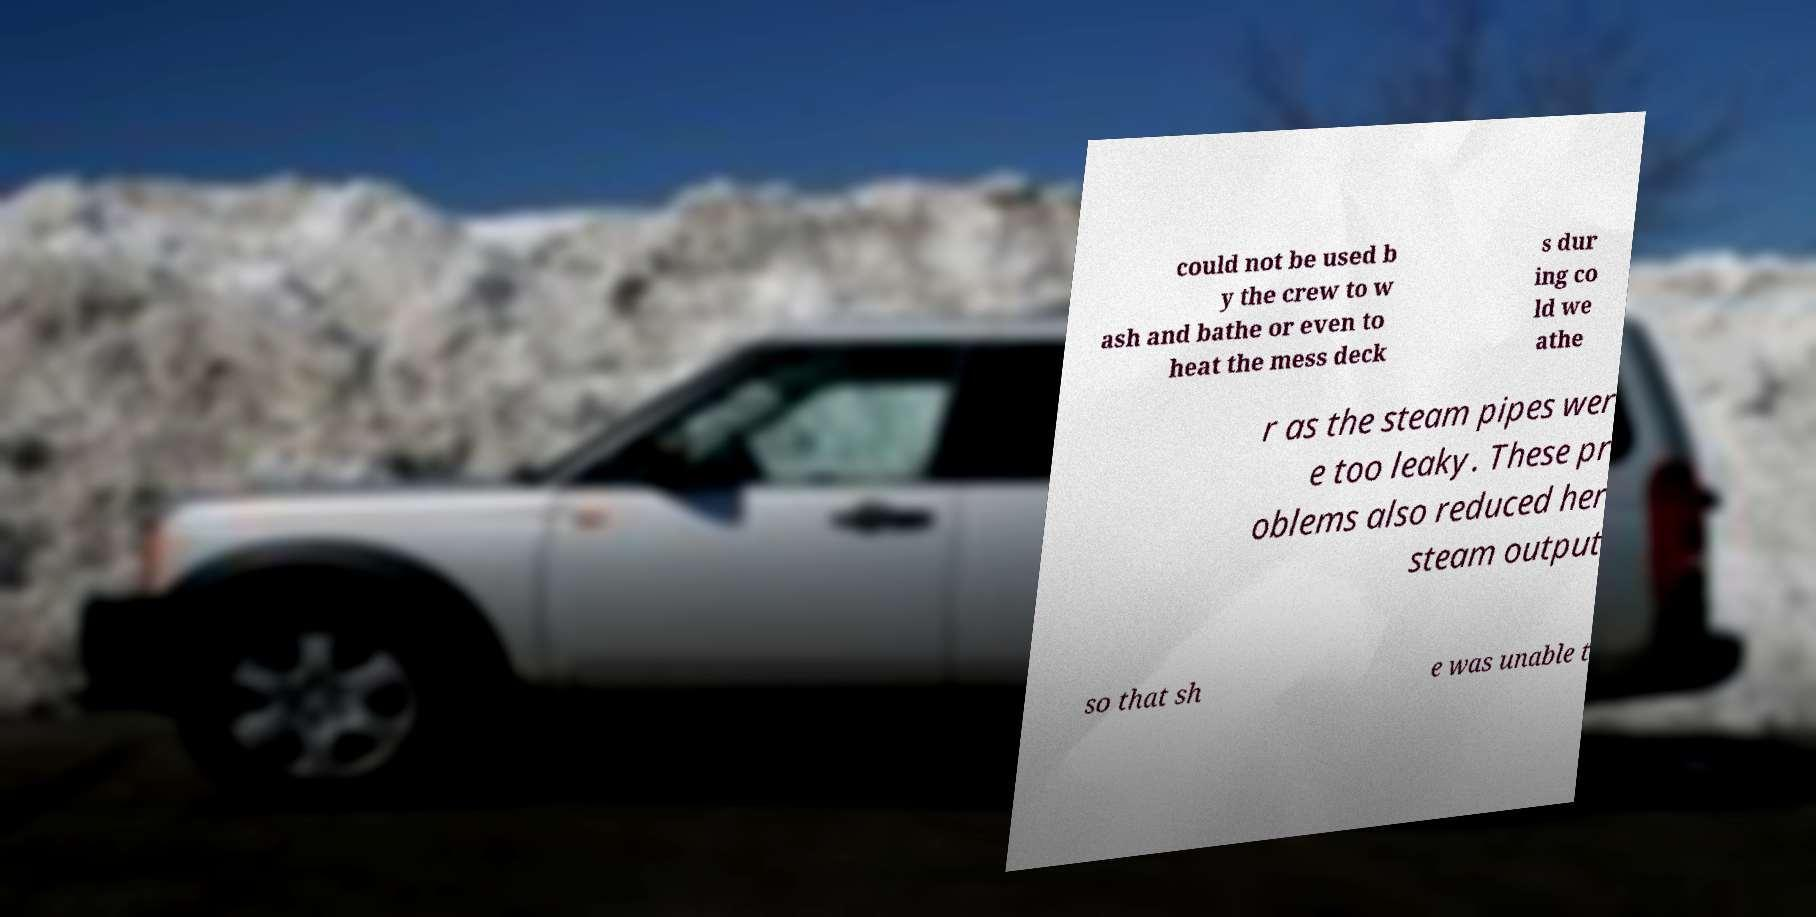For documentation purposes, I need the text within this image transcribed. Could you provide that? could not be used b y the crew to w ash and bathe or even to heat the mess deck s dur ing co ld we athe r as the steam pipes wer e too leaky. These pr oblems also reduced her steam output so that sh e was unable t 